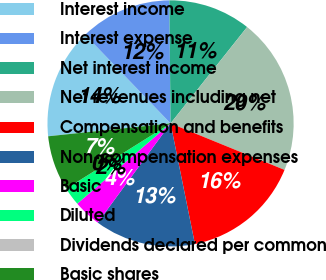Convert chart to OTSL. <chart><loc_0><loc_0><loc_500><loc_500><pie_chart><fcel>Interest income<fcel>Interest expense<fcel>Net interest income<fcel>Net revenues including net<fcel>Compensation and benefits<fcel>Non-compensation expenses<fcel>Basic<fcel>Diluted<fcel>Dividends declared per common<fcel>Basic shares<nl><fcel>14.46%<fcel>12.05%<fcel>10.84%<fcel>20.48%<fcel>15.66%<fcel>13.25%<fcel>3.61%<fcel>2.41%<fcel>0.0%<fcel>7.23%<nl></chart> 